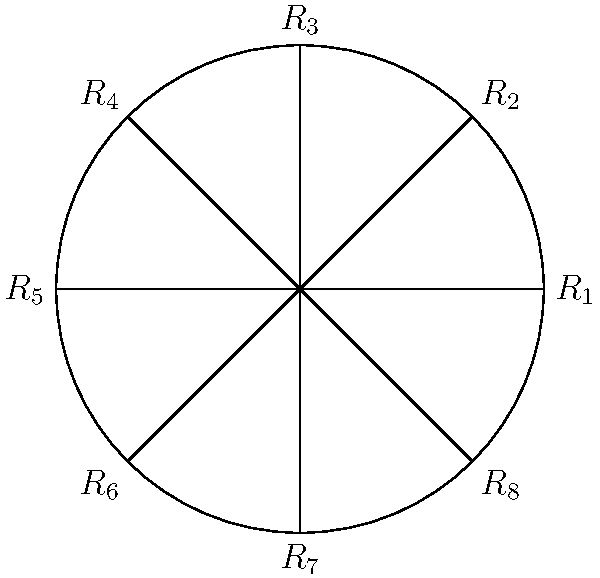St. Stephen's Cathedral's roof features an octagonal pattern of tiles. The diagram represents this pattern, where each $R_i$ corresponds to a $45^\circ$ rotation. If we define the group of rotational symmetries as $G = \{R_1, R_2, ..., R_8\}$, what is the order of the element $R_2$ in this group? To find the order of $R_2$, we need to determine the smallest positive integer $n$ such that $(R_2)^n = R_1$ (the identity element).

Step 1: Understand what $R_2$ represents
$R_2$ is a rotation by $45^\circ$ clockwise.

Step 2: Apply $R_2$ multiple times
$(R_2)^1 = R_2$ (rotation by $45^\circ$)
$(R_2)^2 = R_3$ (rotation by $90^\circ$)
$(R_2)^3 = R_4$ (rotation by $135^\circ$)
$(R_2)^4 = R_5$ (rotation by $180^\circ$)
$(R_2)^5 = R_6$ (rotation by $225^\circ$)
$(R_2)^6 = R_7$ (rotation by $270^\circ$)
$(R_2)^7 = R_8$ (rotation by $315^\circ$)
$(R_2)^8 = R_1$ (rotation by $360^\circ = 0^\circ$)

Step 3: Identify the smallest $n$ where $(R_2)^n = R_1$
We see that when $n = 8$, we return to the identity element $R_1$.

Therefore, the order of $R_2$ in the group $G$ is 8.
Answer: 8 